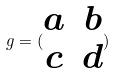Convert formula to latex. <formula><loc_0><loc_0><loc_500><loc_500>g = ( \begin{matrix} a & b \\ c & d \end{matrix} )</formula> 